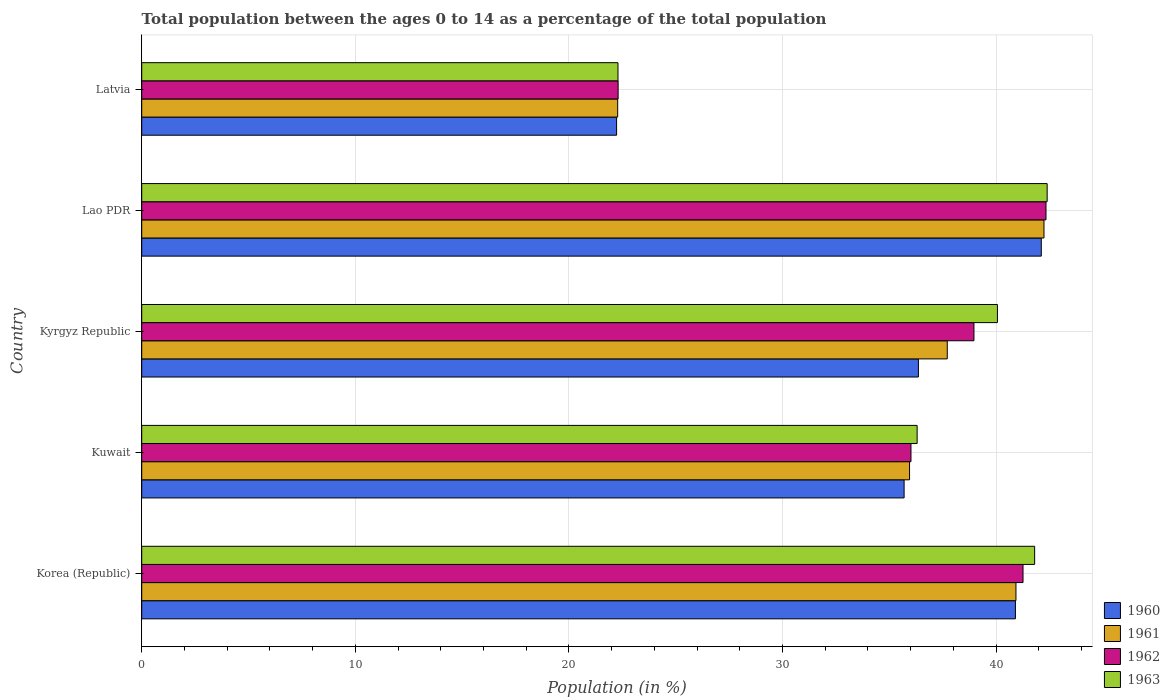How many groups of bars are there?
Your response must be concise. 5. How many bars are there on the 5th tick from the top?
Give a very brief answer. 4. What is the label of the 5th group of bars from the top?
Your answer should be compact. Korea (Republic). In how many cases, is the number of bars for a given country not equal to the number of legend labels?
Give a very brief answer. 0. What is the percentage of the population ages 0 to 14 in 1963 in Kuwait?
Offer a terse response. 36.31. Across all countries, what is the maximum percentage of the population ages 0 to 14 in 1961?
Offer a terse response. 42.24. Across all countries, what is the minimum percentage of the population ages 0 to 14 in 1962?
Give a very brief answer. 22.31. In which country was the percentage of the population ages 0 to 14 in 1963 maximum?
Keep it short and to the point. Lao PDR. In which country was the percentage of the population ages 0 to 14 in 1960 minimum?
Make the answer very short. Latvia. What is the total percentage of the population ages 0 to 14 in 1963 in the graph?
Ensure brevity in your answer.  182.87. What is the difference between the percentage of the population ages 0 to 14 in 1960 in Korea (Republic) and that in Kuwait?
Give a very brief answer. 5.21. What is the difference between the percentage of the population ages 0 to 14 in 1963 in Kuwait and the percentage of the population ages 0 to 14 in 1962 in Latvia?
Offer a very short reply. 14. What is the average percentage of the population ages 0 to 14 in 1963 per country?
Ensure brevity in your answer.  36.57. What is the difference between the percentage of the population ages 0 to 14 in 1962 and percentage of the population ages 0 to 14 in 1963 in Kyrgyz Republic?
Give a very brief answer. -1.1. What is the ratio of the percentage of the population ages 0 to 14 in 1961 in Kuwait to that in Latvia?
Provide a short and direct response. 1.61. What is the difference between the highest and the second highest percentage of the population ages 0 to 14 in 1962?
Provide a succinct answer. 1.08. What is the difference between the highest and the lowest percentage of the population ages 0 to 14 in 1960?
Give a very brief answer. 19.88. Is the sum of the percentage of the population ages 0 to 14 in 1962 in Korea (Republic) and Kyrgyz Republic greater than the maximum percentage of the population ages 0 to 14 in 1961 across all countries?
Offer a terse response. Yes. What does the 4th bar from the bottom in Lao PDR represents?
Your answer should be very brief. 1963. Is it the case that in every country, the sum of the percentage of the population ages 0 to 14 in 1960 and percentage of the population ages 0 to 14 in 1961 is greater than the percentage of the population ages 0 to 14 in 1962?
Your answer should be very brief. Yes. How many bars are there?
Provide a succinct answer. 20. Are all the bars in the graph horizontal?
Offer a terse response. Yes. Are the values on the major ticks of X-axis written in scientific E-notation?
Offer a very short reply. No. Does the graph contain any zero values?
Keep it short and to the point. No. Does the graph contain grids?
Provide a succinct answer. Yes. Where does the legend appear in the graph?
Offer a terse response. Bottom right. How are the legend labels stacked?
Your answer should be compact. Vertical. What is the title of the graph?
Offer a terse response. Total population between the ages 0 to 14 as a percentage of the total population. What is the label or title of the X-axis?
Make the answer very short. Population (in %). What is the label or title of the Y-axis?
Make the answer very short. Country. What is the Population (in %) in 1960 in Korea (Republic)?
Provide a short and direct response. 40.91. What is the Population (in %) of 1961 in Korea (Republic)?
Your answer should be very brief. 40.93. What is the Population (in %) of 1962 in Korea (Republic)?
Your answer should be compact. 41.26. What is the Population (in %) of 1963 in Korea (Republic)?
Your answer should be compact. 41.81. What is the Population (in %) of 1960 in Kuwait?
Provide a short and direct response. 35.7. What is the Population (in %) in 1961 in Kuwait?
Make the answer very short. 35.95. What is the Population (in %) of 1962 in Kuwait?
Keep it short and to the point. 36.02. What is the Population (in %) in 1963 in Kuwait?
Make the answer very short. 36.31. What is the Population (in %) in 1960 in Kyrgyz Republic?
Offer a very short reply. 36.36. What is the Population (in %) of 1961 in Kyrgyz Republic?
Your response must be concise. 37.72. What is the Population (in %) in 1962 in Kyrgyz Republic?
Your answer should be compact. 38.97. What is the Population (in %) in 1963 in Kyrgyz Republic?
Offer a very short reply. 40.06. What is the Population (in %) of 1960 in Lao PDR?
Offer a very short reply. 42.12. What is the Population (in %) of 1961 in Lao PDR?
Keep it short and to the point. 42.24. What is the Population (in %) in 1962 in Lao PDR?
Offer a terse response. 42.34. What is the Population (in %) of 1963 in Lao PDR?
Ensure brevity in your answer.  42.39. What is the Population (in %) of 1960 in Latvia?
Your response must be concise. 22.23. What is the Population (in %) in 1961 in Latvia?
Provide a short and direct response. 22.29. What is the Population (in %) in 1962 in Latvia?
Ensure brevity in your answer.  22.31. What is the Population (in %) in 1963 in Latvia?
Offer a terse response. 22.3. Across all countries, what is the maximum Population (in %) in 1960?
Offer a very short reply. 42.12. Across all countries, what is the maximum Population (in %) in 1961?
Your answer should be compact. 42.24. Across all countries, what is the maximum Population (in %) in 1962?
Offer a terse response. 42.34. Across all countries, what is the maximum Population (in %) of 1963?
Your response must be concise. 42.39. Across all countries, what is the minimum Population (in %) in 1960?
Provide a succinct answer. 22.23. Across all countries, what is the minimum Population (in %) of 1961?
Keep it short and to the point. 22.29. Across all countries, what is the minimum Population (in %) of 1962?
Offer a very short reply. 22.31. Across all countries, what is the minimum Population (in %) in 1963?
Keep it short and to the point. 22.3. What is the total Population (in %) of 1960 in the graph?
Give a very brief answer. 177.32. What is the total Population (in %) of 1961 in the graph?
Your answer should be compact. 179.13. What is the total Population (in %) of 1962 in the graph?
Provide a short and direct response. 180.89. What is the total Population (in %) in 1963 in the graph?
Your answer should be very brief. 182.87. What is the difference between the Population (in %) in 1960 in Korea (Republic) and that in Kuwait?
Provide a succinct answer. 5.21. What is the difference between the Population (in %) in 1961 in Korea (Republic) and that in Kuwait?
Offer a very short reply. 4.98. What is the difference between the Population (in %) of 1962 in Korea (Republic) and that in Kuwait?
Offer a terse response. 5.25. What is the difference between the Population (in %) in 1963 in Korea (Republic) and that in Kuwait?
Keep it short and to the point. 5.5. What is the difference between the Population (in %) of 1960 in Korea (Republic) and that in Kyrgyz Republic?
Offer a terse response. 4.54. What is the difference between the Population (in %) of 1961 in Korea (Republic) and that in Kyrgyz Republic?
Offer a terse response. 3.22. What is the difference between the Population (in %) in 1962 in Korea (Republic) and that in Kyrgyz Republic?
Provide a short and direct response. 2.3. What is the difference between the Population (in %) in 1963 in Korea (Republic) and that in Kyrgyz Republic?
Ensure brevity in your answer.  1.74. What is the difference between the Population (in %) in 1960 in Korea (Republic) and that in Lao PDR?
Your answer should be compact. -1.21. What is the difference between the Population (in %) in 1961 in Korea (Republic) and that in Lao PDR?
Your answer should be compact. -1.31. What is the difference between the Population (in %) in 1962 in Korea (Republic) and that in Lao PDR?
Your answer should be very brief. -1.08. What is the difference between the Population (in %) of 1963 in Korea (Republic) and that in Lao PDR?
Provide a succinct answer. -0.59. What is the difference between the Population (in %) in 1960 in Korea (Republic) and that in Latvia?
Offer a terse response. 18.67. What is the difference between the Population (in %) in 1961 in Korea (Republic) and that in Latvia?
Offer a very short reply. 18.65. What is the difference between the Population (in %) in 1962 in Korea (Republic) and that in Latvia?
Your answer should be compact. 18.96. What is the difference between the Population (in %) in 1963 in Korea (Republic) and that in Latvia?
Provide a succinct answer. 19.51. What is the difference between the Population (in %) of 1960 in Kuwait and that in Kyrgyz Republic?
Ensure brevity in your answer.  -0.67. What is the difference between the Population (in %) in 1961 in Kuwait and that in Kyrgyz Republic?
Keep it short and to the point. -1.77. What is the difference between the Population (in %) of 1962 in Kuwait and that in Kyrgyz Republic?
Make the answer very short. -2.95. What is the difference between the Population (in %) in 1963 in Kuwait and that in Kyrgyz Republic?
Provide a succinct answer. -3.76. What is the difference between the Population (in %) in 1960 in Kuwait and that in Lao PDR?
Offer a very short reply. -6.42. What is the difference between the Population (in %) in 1961 in Kuwait and that in Lao PDR?
Provide a succinct answer. -6.29. What is the difference between the Population (in %) in 1962 in Kuwait and that in Lao PDR?
Keep it short and to the point. -6.32. What is the difference between the Population (in %) of 1963 in Kuwait and that in Lao PDR?
Offer a very short reply. -6.09. What is the difference between the Population (in %) in 1960 in Kuwait and that in Latvia?
Provide a succinct answer. 13.46. What is the difference between the Population (in %) of 1961 in Kuwait and that in Latvia?
Your answer should be compact. 13.66. What is the difference between the Population (in %) in 1962 in Kuwait and that in Latvia?
Offer a very short reply. 13.71. What is the difference between the Population (in %) in 1963 in Kuwait and that in Latvia?
Offer a terse response. 14.01. What is the difference between the Population (in %) of 1960 in Kyrgyz Republic and that in Lao PDR?
Offer a very short reply. -5.75. What is the difference between the Population (in %) of 1961 in Kyrgyz Republic and that in Lao PDR?
Provide a short and direct response. -4.53. What is the difference between the Population (in %) in 1962 in Kyrgyz Republic and that in Lao PDR?
Offer a very short reply. -3.37. What is the difference between the Population (in %) of 1963 in Kyrgyz Republic and that in Lao PDR?
Offer a very short reply. -2.33. What is the difference between the Population (in %) of 1960 in Kyrgyz Republic and that in Latvia?
Offer a terse response. 14.13. What is the difference between the Population (in %) of 1961 in Kyrgyz Republic and that in Latvia?
Provide a succinct answer. 15.43. What is the difference between the Population (in %) of 1962 in Kyrgyz Republic and that in Latvia?
Give a very brief answer. 16.66. What is the difference between the Population (in %) in 1963 in Kyrgyz Republic and that in Latvia?
Your answer should be very brief. 17.77. What is the difference between the Population (in %) of 1960 in Lao PDR and that in Latvia?
Ensure brevity in your answer.  19.88. What is the difference between the Population (in %) of 1961 in Lao PDR and that in Latvia?
Provide a succinct answer. 19.96. What is the difference between the Population (in %) in 1962 in Lao PDR and that in Latvia?
Offer a very short reply. 20.03. What is the difference between the Population (in %) of 1963 in Lao PDR and that in Latvia?
Offer a very short reply. 20.09. What is the difference between the Population (in %) in 1960 in Korea (Republic) and the Population (in %) in 1961 in Kuwait?
Give a very brief answer. 4.96. What is the difference between the Population (in %) in 1960 in Korea (Republic) and the Population (in %) in 1962 in Kuwait?
Offer a very short reply. 4.89. What is the difference between the Population (in %) in 1960 in Korea (Republic) and the Population (in %) in 1963 in Kuwait?
Offer a very short reply. 4.6. What is the difference between the Population (in %) in 1961 in Korea (Republic) and the Population (in %) in 1962 in Kuwait?
Your answer should be very brief. 4.92. What is the difference between the Population (in %) of 1961 in Korea (Republic) and the Population (in %) of 1963 in Kuwait?
Provide a short and direct response. 4.63. What is the difference between the Population (in %) of 1962 in Korea (Republic) and the Population (in %) of 1963 in Kuwait?
Offer a terse response. 4.96. What is the difference between the Population (in %) of 1960 in Korea (Republic) and the Population (in %) of 1961 in Kyrgyz Republic?
Your response must be concise. 3.19. What is the difference between the Population (in %) of 1960 in Korea (Republic) and the Population (in %) of 1962 in Kyrgyz Republic?
Give a very brief answer. 1.94. What is the difference between the Population (in %) of 1960 in Korea (Republic) and the Population (in %) of 1963 in Kyrgyz Republic?
Keep it short and to the point. 0.84. What is the difference between the Population (in %) in 1961 in Korea (Republic) and the Population (in %) in 1962 in Kyrgyz Republic?
Your answer should be compact. 1.97. What is the difference between the Population (in %) in 1961 in Korea (Republic) and the Population (in %) in 1963 in Kyrgyz Republic?
Offer a terse response. 0.87. What is the difference between the Population (in %) in 1962 in Korea (Republic) and the Population (in %) in 1963 in Kyrgyz Republic?
Your answer should be compact. 1.2. What is the difference between the Population (in %) of 1960 in Korea (Republic) and the Population (in %) of 1961 in Lao PDR?
Provide a short and direct response. -1.34. What is the difference between the Population (in %) of 1960 in Korea (Republic) and the Population (in %) of 1962 in Lao PDR?
Make the answer very short. -1.43. What is the difference between the Population (in %) in 1960 in Korea (Republic) and the Population (in %) in 1963 in Lao PDR?
Give a very brief answer. -1.49. What is the difference between the Population (in %) in 1961 in Korea (Republic) and the Population (in %) in 1962 in Lao PDR?
Your response must be concise. -1.41. What is the difference between the Population (in %) of 1961 in Korea (Republic) and the Population (in %) of 1963 in Lao PDR?
Make the answer very short. -1.46. What is the difference between the Population (in %) in 1962 in Korea (Republic) and the Population (in %) in 1963 in Lao PDR?
Provide a succinct answer. -1.13. What is the difference between the Population (in %) in 1960 in Korea (Republic) and the Population (in %) in 1961 in Latvia?
Keep it short and to the point. 18.62. What is the difference between the Population (in %) in 1960 in Korea (Republic) and the Population (in %) in 1962 in Latvia?
Make the answer very short. 18.6. What is the difference between the Population (in %) of 1960 in Korea (Republic) and the Population (in %) of 1963 in Latvia?
Offer a terse response. 18.61. What is the difference between the Population (in %) of 1961 in Korea (Republic) and the Population (in %) of 1962 in Latvia?
Offer a very short reply. 18.63. What is the difference between the Population (in %) of 1961 in Korea (Republic) and the Population (in %) of 1963 in Latvia?
Provide a short and direct response. 18.63. What is the difference between the Population (in %) of 1962 in Korea (Republic) and the Population (in %) of 1963 in Latvia?
Your answer should be compact. 18.96. What is the difference between the Population (in %) in 1960 in Kuwait and the Population (in %) in 1961 in Kyrgyz Republic?
Offer a terse response. -2.02. What is the difference between the Population (in %) of 1960 in Kuwait and the Population (in %) of 1962 in Kyrgyz Republic?
Ensure brevity in your answer.  -3.27. What is the difference between the Population (in %) in 1960 in Kuwait and the Population (in %) in 1963 in Kyrgyz Republic?
Give a very brief answer. -4.37. What is the difference between the Population (in %) in 1961 in Kuwait and the Population (in %) in 1962 in Kyrgyz Republic?
Provide a short and direct response. -3.02. What is the difference between the Population (in %) in 1961 in Kuwait and the Population (in %) in 1963 in Kyrgyz Republic?
Give a very brief answer. -4.11. What is the difference between the Population (in %) in 1962 in Kuwait and the Population (in %) in 1963 in Kyrgyz Republic?
Give a very brief answer. -4.05. What is the difference between the Population (in %) in 1960 in Kuwait and the Population (in %) in 1961 in Lao PDR?
Offer a very short reply. -6.55. What is the difference between the Population (in %) in 1960 in Kuwait and the Population (in %) in 1962 in Lao PDR?
Give a very brief answer. -6.64. What is the difference between the Population (in %) in 1960 in Kuwait and the Population (in %) in 1963 in Lao PDR?
Your response must be concise. -6.7. What is the difference between the Population (in %) in 1961 in Kuwait and the Population (in %) in 1962 in Lao PDR?
Give a very brief answer. -6.39. What is the difference between the Population (in %) of 1961 in Kuwait and the Population (in %) of 1963 in Lao PDR?
Provide a short and direct response. -6.44. What is the difference between the Population (in %) of 1962 in Kuwait and the Population (in %) of 1963 in Lao PDR?
Give a very brief answer. -6.38. What is the difference between the Population (in %) in 1960 in Kuwait and the Population (in %) in 1961 in Latvia?
Your response must be concise. 13.41. What is the difference between the Population (in %) of 1960 in Kuwait and the Population (in %) of 1962 in Latvia?
Provide a succinct answer. 13.39. What is the difference between the Population (in %) in 1960 in Kuwait and the Population (in %) in 1963 in Latvia?
Provide a short and direct response. 13.4. What is the difference between the Population (in %) of 1961 in Kuwait and the Population (in %) of 1962 in Latvia?
Make the answer very short. 13.64. What is the difference between the Population (in %) in 1961 in Kuwait and the Population (in %) in 1963 in Latvia?
Keep it short and to the point. 13.65. What is the difference between the Population (in %) of 1962 in Kuwait and the Population (in %) of 1963 in Latvia?
Provide a short and direct response. 13.72. What is the difference between the Population (in %) in 1960 in Kyrgyz Republic and the Population (in %) in 1961 in Lao PDR?
Keep it short and to the point. -5.88. What is the difference between the Population (in %) of 1960 in Kyrgyz Republic and the Population (in %) of 1962 in Lao PDR?
Offer a terse response. -5.97. What is the difference between the Population (in %) in 1960 in Kyrgyz Republic and the Population (in %) in 1963 in Lao PDR?
Your response must be concise. -6.03. What is the difference between the Population (in %) of 1961 in Kyrgyz Republic and the Population (in %) of 1962 in Lao PDR?
Offer a very short reply. -4.62. What is the difference between the Population (in %) of 1961 in Kyrgyz Republic and the Population (in %) of 1963 in Lao PDR?
Your answer should be compact. -4.68. What is the difference between the Population (in %) of 1962 in Kyrgyz Republic and the Population (in %) of 1963 in Lao PDR?
Provide a short and direct response. -3.43. What is the difference between the Population (in %) in 1960 in Kyrgyz Republic and the Population (in %) in 1961 in Latvia?
Offer a terse response. 14.08. What is the difference between the Population (in %) in 1960 in Kyrgyz Republic and the Population (in %) in 1962 in Latvia?
Your answer should be very brief. 14.06. What is the difference between the Population (in %) of 1960 in Kyrgyz Republic and the Population (in %) of 1963 in Latvia?
Give a very brief answer. 14.07. What is the difference between the Population (in %) of 1961 in Kyrgyz Republic and the Population (in %) of 1962 in Latvia?
Make the answer very short. 15.41. What is the difference between the Population (in %) of 1961 in Kyrgyz Republic and the Population (in %) of 1963 in Latvia?
Your answer should be very brief. 15.42. What is the difference between the Population (in %) in 1962 in Kyrgyz Republic and the Population (in %) in 1963 in Latvia?
Provide a short and direct response. 16.67. What is the difference between the Population (in %) in 1960 in Lao PDR and the Population (in %) in 1961 in Latvia?
Offer a terse response. 19.83. What is the difference between the Population (in %) of 1960 in Lao PDR and the Population (in %) of 1962 in Latvia?
Make the answer very short. 19.81. What is the difference between the Population (in %) of 1960 in Lao PDR and the Population (in %) of 1963 in Latvia?
Your response must be concise. 19.82. What is the difference between the Population (in %) in 1961 in Lao PDR and the Population (in %) in 1962 in Latvia?
Provide a succinct answer. 19.94. What is the difference between the Population (in %) in 1961 in Lao PDR and the Population (in %) in 1963 in Latvia?
Offer a terse response. 19.95. What is the difference between the Population (in %) in 1962 in Lao PDR and the Population (in %) in 1963 in Latvia?
Ensure brevity in your answer.  20.04. What is the average Population (in %) of 1960 per country?
Provide a succinct answer. 35.46. What is the average Population (in %) in 1961 per country?
Your answer should be very brief. 35.83. What is the average Population (in %) in 1962 per country?
Offer a very short reply. 36.18. What is the average Population (in %) of 1963 per country?
Keep it short and to the point. 36.57. What is the difference between the Population (in %) in 1960 and Population (in %) in 1961 in Korea (Republic)?
Your response must be concise. -0.02. What is the difference between the Population (in %) in 1960 and Population (in %) in 1962 in Korea (Republic)?
Offer a very short reply. -0.36. What is the difference between the Population (in %) in 1960 and Population (in %) in 1963 in Korea (Republic)?
Offer a very short reply. -0.9. What is the difference between the Population (in %) of 1961 and Population (in %) of 1962 in Korea (Republic)?
Your response must be concise. -0.33. What is the difference between the Population (in %) in 1961 and Population (in %) in 1963 in Korea (Republic)?
Provide a succinct answer. -0.88. What is the difference between the Population (in %) in 1962 and Population (in %) in 1963 in Korea (Republic)?
Keep it short and to the point. -0.54. What is the difference between the Population (in %) of 1960 and Population (in %) of 1961 in Kuwait?
Your answer should be very brief. -0.25. What is the difference between the Population (in %) in 1960 and Population (in %) in 1962 in Kuwait?
Ensure brevity in your answer.  -0.32. What is the difference between the Population (in %) in 1960 and Population (in %) in 1963 in Kuwait?
Offer a terse response. -0.61. What is the difference between the Population (in %) of 1961 and Population (in %) of 1962 in Kuwait?
Provide a succinct answer. -0.07. What is the difference between the Population (in %) in 1961 and Population (in %) in 1963 in Kuwait?
Your answer should be very brief. -0.36. What is the difference between the Population (in %) of 1962 and Population (in %) of 1963 in Kuwait?
Your answer should be compact. -0.29. What is the difference between the Population (in %) in 1960 and Population (in %) in 1961 in Kyrgyz Republic?
Your response must be concise. -1.35. What is the difference between the Population (in %) in 1960 and Population (in %) in 1962 in Kyrgyz Republic?
Ensure brevity in your answer.  -2.6. What is the difference between the Population (in %) in 1960 and Population (in %) in 1963 in Kyrgyz Republic?
Give a very brief answer. -3.7. What is the difference between the Population (in %) in 1961 and Population (in %) in 1962 in Kyrgyz Republic?
Offer a very short reply. -1.25. What is the difference between the Population (in %) in 1961 and Population (in %) in 1963 in Kyrgyz Republic?
Provide a succinct answer. -2.35. What is the difference between the Population (in %) of 1962 and Population (in %) of 1963 in Kyrgyz Republic?
Offer a terse response. -1.1. What is the difference between the Population (in %) in 1960 and Population (in %) in 1961 in Lao PDR?
Offer a very short reply. -0.13. What is the difference between the Population (in %) in 1960 and Population (in %) in 1962 in Lao PDR?
Make the answer very short. -0.22. What is the difference between the Population (in %) of 1960 and Population (in %) of 1963 in Lao PDR?
Make the answer very short. -0.27. What is the difference between the Population (in %) of 1961 and Population (in %) of 1962 in Lao PDR?
Make the answer very short. -0.09. What is the difference between the Population (in %) of 1961 and Population (in %) of 1963 in Lao PDR?
Provide a short and direct response. -0.15. What is the difference between the Population (in %) of 1962 and Population (in %) of 1963 in Lao PDR?
Ensure brevity in your answer.  -0.05. What is the difference between the Population (in %) of 1960 and Population (in %) of 1961 in Latvia?
Provide a succinct answer. -0.05. What is the difference between the Population (in %) in 1960 and Population (in %) in 1962 in Latvia?
Keep it short and to the point. -0.07. What is the difference between the Population (in %) of 1960 and Population (in %) of 1963 in Latvia?
Offer a very short reply. -0.06. What is the difference between the Population (in %) of 1961 and Population (in %) of 1962 in Latvia?
Your response must be concise. -0.02. What is the difference between the Population (in %) of 1961 and Population (in %) of 1963 in Latvia?
Make the answer very short. -0.01. What is the difference between the Population (in %) in 1962 and Population (in %) in 1963 in Latvia?
Provide a short and direct response. 0.01. What is the ratio of the Population (in %) in 1960 in Korea (Republic) to that in Kuwait?
Your response must be concise. 1.15. What is the ratio of the Population (in %) in 1961 in Korea (Republic) to that in Kuwait?
Give a very brief answer. 1.14. What is the ratio of the Population (in %) in 1962 in Korea (Republic) to that in Kuwait?
Your answer should be compact. 1.15. What is the ratio of the Population (in %) in 1963 in Korea (Republic) to that in Kuwait?
Provide a succinct answer. 1.15. What is the ratio of the Population (in %) of 1960 in Korea (Republic) to that in Kyrgyz Republic?
Ensure brevity in your answer.  1.12. What is the ratio of the Population (in %) of 1961 in Korea (Republic) to that in Kyrgyz Republic?
Provide a succinct answer. 1.09. What is the ratio of the Population (in %) in 1962 in Korea (Republic) to that in Kyrgyz Republic?
Make the answer very short. 1.06. What is the ratio of the Population (in %) in 1963 in Korea (Republic) to that in Kyrgyz Republic?
Ensure brevity in your answer.  1.04. What is the ratio of the Population (in %) of 1960 in Korea (Republic) to that in Lao PDR?
Keep it short and to the point. 0.97. What is the ratio of the Population (in %) in 1961 in Korea (Republic) to that in Lao PDR?
Provide a short and direct response. 0.97. What is the ratio of the Population (in %) of 1962 in Korea (Republic) to that in Lao PDR?
Give a very brief answer. 0.97. What is the ratio of the Population (in %) of 1963 in Korea (Republic) to that in Lao PDR?
Keep it short and to the point. 0.99. What is the ratio of the Population (in %) of 1960 in Korea (Republic) to that in Latvia?
Provide a short and direct response. 1.84. What is the ratio of the Population (in %) in 1961 in Korea (Republic) to that in Latvia?
Ensure brevity in your answer.  1.84. What is the ratio of the Population (in %) of 1962 in Korea (Republic) to that in Latvia?
Offer a terse response. 1.85. What is the ratio of the Population (in %) in 1963 in Korea (Republic) to that in Latvia?
Offer a terse response. 1.87. What is the ratio of the Population (in %) in 1960 in Kuwait to that in Kyrgyz Republic?
Give a very brief answer. 0.98. What is the ratio of the Population (in %) in 1961 in Kuwait to that in Kyrgyz Republic?
Give a very brief answer. 0.95. What is the ratio of the Population (in %) in 1962 in Kuwait to that in Kyrgyz Republic?
Offer a terse response. 0.92. What is the ratio of the Population (in %) of 1963 in Kuwait to that in Kyrgyz Republic?
Offer a very short reply. 0.91. What is the ratio of the Population (in %) of 1960 in Kuwait to that in Lao PDR?
Give a very brief answer. 0.85. What is the ratio of the Population (in %) of 1961 in Kuwait to that in Lao PDR?
Your response must be concise. 0.85. What is the ratio of the Population (in %) of 1962 in Kuwait to that in Lao PDR?
Your answer should be compact. 0.85. What is the ratio of the Population (in %) in 1963 in Kuwait to that in Lao PDR?
Ensure brevity in your answer.  0.86. What is the ratio of the Population (in %) in 1960 in Kuwait to that in Latvia?
Provide a short and direct response. 1.61. What is the ratio of the Population (in %) in 1961 in Kuwait to that in Latvia?
Make the answer very short. 1.61. What is the ratio of the Population (in %) in 1962 in Kuwait to that in Latvia?
Ensure brevity in your answer.  1.61. What is the ratio of the Population (in %) of 1963 in Kuwait to that in Latvia?
Offer a very short reply. 1.63. What is the ratio of the Population (in %) of 1960 in Kyrgyz Republic to that in Lao PDR?
Keep it short and to the point. 0.86. What is the ratio of the Population (in %) in 1961 in Kyrgyz Republic to that in Lao PDR?
Your answer should be very brief. 0.89. What is the ratio of the Population (in %) of 1962 in Kyrgyz Republic to that in Lao PDR?
Keep it short and to the point. 0.92. What is the ratio of the Population (in %) in 1963 in Kyrgyz Republic to that in Lao PDR?
Offer a very short reply. 0.95. What is the ratio of the Population (in %) of 1960 in Kyrgyz Republic to that in Latvia?
Give a very brief answer. 1.64. What is the ratio of the Population (in %) in 1961 in Kyrgyz Republic to that in Latvia?
Offer a very short reply. 1.69. What is the ratio of the Population (in %) of 1962 in Kyrgyz Republic to that in Latvia?
Give a very brief answer. 1.75. What is the ratio of the Population (in %) of 1963 in Kyrgyz Republic to that in Latvia?
Keep it short and to the point. 1.8. What is the ratio of the Population (in %) in 1960 in Lao PDR to that in Latvia?
Offer a terse response. 1.89. What is the ratio of the Population (in %) of 1961 in Lao PDR to that in Latvia?
Offer a very short reply. 1.9. What is the ratio of the Population (in %) of 1962 in Lao PDR to that in Latvia?
Give a very brief answer. 1.9. What is the ratio of the Population (in %) in 1963 in Lao PDR to that in Latvia?
Make the answer very short. 1.9. What is the difference between the highest and the second highest Population (in %) of 1960?
Ensure brevity in your answer.  1.21. What is the difference between the highest and the second highest Population (in %) of 1961?
Provide a succinct answer. 1.31. What is the difference between the highest and the second highest Population (in %) of 1962?
Provide a short and direct response. 1.08. What is the difference between the highest and the second highest Population (in %) in 1963?
Give a very brief answer. 0.59. What is the difference between the highest and the lowest Population (in %) of 1960?
Ensure brevity in your answer.  19.88. What is the difference between the highest and the lowest Population (in %) of 1961?
Your answer should be very brief. 19.96. What is the difference between the highest and the lowest Population (in %) of 1962?
Your answer should be compact. 20.03. What is the difference between the highest and the lowest Population (in %) in 1963?
Ensure brevity in your answer.  20.09. 